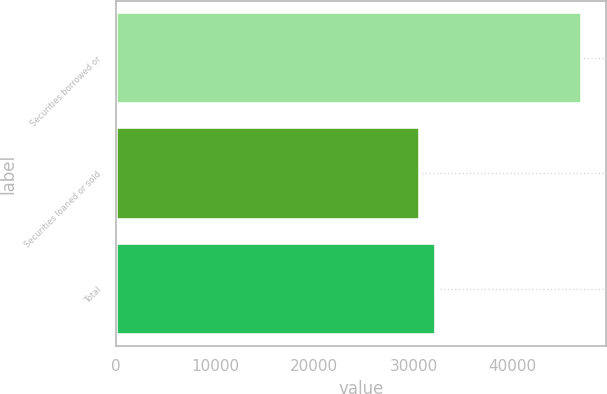Convert chart to OTSL. <chart><loc_0><loc_0><loc_500><loc_500><bar_chart><fcel>Securities borrowed or<fcel>Securities loaned or sold<fcel>Total<nl><fcel>47027<fcel>30652<fcel>32289.5<nl></chart> 